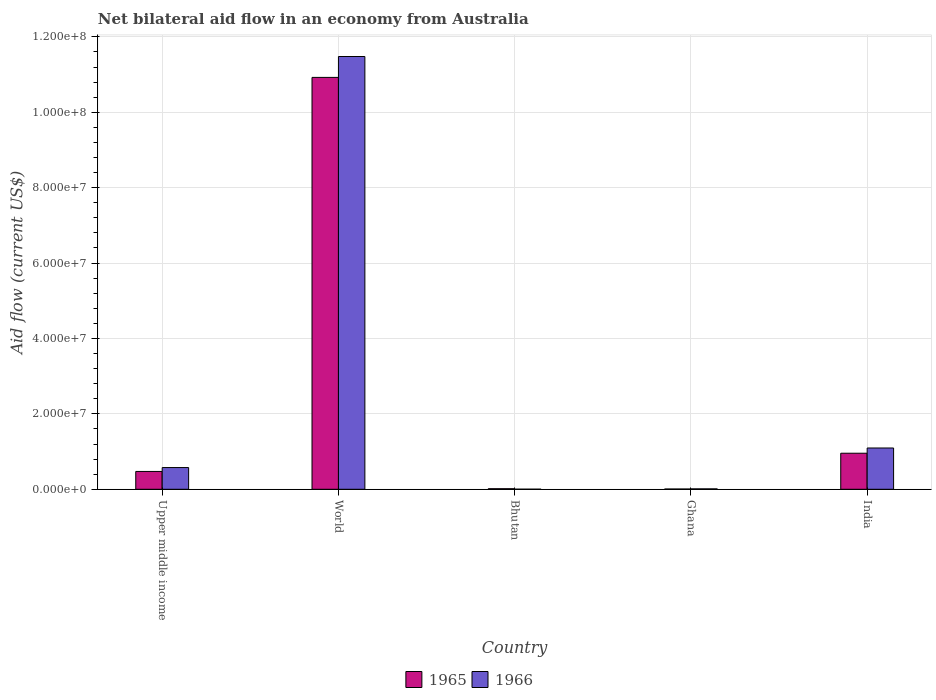How many different coloured bars are there?
Your response must be concise. 2. How many groups of bars are there?
Provide a succinct answer. 5. How many bars are there on the 4th tick from the left?
Your answer should be very brief. 2. How many bars are there on the 4th tick from the right?
Provide a short and direct response. 2. In how many cases, is the number of bars for a given country not equal to the number of legend labels?
Your answer should be compact. 0. Across all countries, what is the maximum net bilateral aid flow in 1965?
Your response must be concise. 1.09e+08. Across all countries, what is the minimum net bilateral aid flow in 1965?
Offer a terse response. 7.00e+04. In which country was the net bilateral aid flow in 1966 minimum?
Keep it short and to the point. Bhutan. What is the total net bilateral aid flow in 1966 in the graph?
Your response must be concise. 1.32e+08. What is the difference between the net bilateral aid flow in 1966 in Ghana and that in India?
Provide a succinct answer. -1.08e+07. What is the difference between the net bilateral aid flow in 1966 in Ghana and the net bilateral aid flow in 1965 in Bhutan?
Offer a very short reply. -4.00e+04. What is the average net bilateral aid flow in 1966 per country?
Give a very brief answer. 2.63e+07. What is the difference between the net bilateral aid flow of/in 1965 and net bilateral aid flow of/in 1966 in India?
Provide a short and direct response. -1.39e+06. What is the ratio of the net bilateral aid flow in 1965 in India to that in Upper middle income?
Keep it short and to the point. 2.02. What is the difference between the highest and the second highest net bilateral aid flow in 1965?
Your response must be concise. 1.05e+08. What is the difference between the highest and the lowest net bilateral aid flow in 1965?
Ensure brevity in your answer.  1.09e+08. In how many countries, is the net bilateral aid flow in 1966 greater than the average net bilateral aid flow in 1966 taken over all countries?
Your answer should be compact. 1. Is the sum of the net bilateral aid flow in 1966 in Bhutan and Upper middle income greater than the maximum net bilateral aid flow in 1965 across all countries?
Ensure brevity in your answer.  No. What does the 1st bar from the left in World represents?
Your response must be concise. 1965. What does the 1st bar from the right in Upper middle income represents?
Offer a very short reply. 1966. How many bars are there?
Your answer should be compact. 10. Are the values on the major ticks of Y-axis written in scientific E-notation?
Give a very brief answer. Yes. Does the graph contain any zero values?
Keep it short and to the point. No. Does the graph contain grids?
Provide a short and direct response. Yes. What is the title of the graph?
Your answer should be compact. Net bilateral aid flow in an economy from Australia. What is the label or title of the Y-axis?
Your answer should be very brief. Aid flow (current US$). What is the Aid flow (current US$) in 1965 in Upper middle income?
Your answer should be compact. 4.73e+06. What is the Aid flow (current US$) in 1966 in Upper middle income?
Provide a short and direct response. 5.76e+06. What is the Aid flow (current US$) of 1965 in World?
Your answer should be compact. 1.09e+08. What is the Aid flow (current US$) in 1966 in World?
Keep it short and to the point. 1.15e+08. What is the Aid flow (current US$) in 1965 in Bhutan?
Provide a short and direct response. 1.50e+05. What is the Aid flow (current US$) in 1966 in Bhutan?
Keep it short and to the point. 2.00e+04. What is the Aid flow (current US$) of 1965 in Ghana?
Provide a succinct answer. 7.00e+04. What is the Aid flow (current US$) in 1965 in India?
Ensure brevity in your answer.  9.56e+06. What is the Aid flow (current US$) of 1966 in India?
Make the answer very short. 1.10e+07. Across all countries, what is the maximum Aid flow (current US$) of 1965?
Ensure brevity in your answer.  1.09e+08. Across all countries, what is the maximum Aid flow (current US$) in 1966?
Ensure brevity in your answer.  1.15e+08. Across all countries, what is the minimum Aid flow (current US$) in 1966?
Your response must be concise. 2.00e+04. What is the total Aid flow (current US$) of 1965 in the graph?
Offer a very short reply. 1.24e+08. What is the total Aid flow (current US$) of 1966 in the graph?
Provide a short and direct response. 1.32e+08. What is the difference between the Aid flow (current US$) of 1965 in Upper middle income and that in World?
Your response must be concise. -1.05e+08. What is the difference between the Aid flow (current US$) in 1966 in Upper middle income and that in World?
Your answer should be very brief. -1.09e+08. What is the difference between the Aid flow (current US$) of 1965 in Upper middle income and that in Bhutan?
Keep it short and to the point. 4.58e+06. What is the difference between the Aid flow (current US$) in 1966 in Upper middle income and that in Bhutan?
Provide a succinct answer. 5.74e+06. What is the difference between the Aid flow (current US$) of 1965 in Upper middle income and that in Ghana?
Your response must be concise. 4.66e+06. What is the difference between the Aid flow (current US$) of 1966 in Upper middle income and that in Ghana?
Provide a succinct answer. 5.65e+06. What is the difference between the Aid flow (current US$) of 1965 in Upper middle income and that in India?
Give a very brief answer. -4.83e+06. What is the difference between the Aid flow (current US$) of 1966 in Upper middle income and that in India?
Your answer should be very brief. -5.19e+06. What is the difference between the Aid flow (current US$) of 1965 in World and that in Bhutan?
Provide a short and direct response. 1.09e+08. What is the difference between the Aid flow (current US$) of 1966 in World and that in Bhutan?
Provide a short and direct response. 1.15e+08. What is the difference between the Aid flow (current US$) in 1965 in World and that in Ghana?
Ensure brevity in your answer.  1.09e+08. What is the difference between the Aid flow (current US$) in 1966 in World and that in Ghana?
Provide a short and direct response. 1.15e+08. What is the difference between the Aid flow (current US$) of 1965 in World and that in India?
Provide a succinct answer. 9.97e+07. What is the difference between the Aid flow (current US$) in 1966 in World and that in India?
Provide a succinct answer. 1.04e+08. What is the difference between the Aid flow (current US$) in 1965 in Bhutan and that in Ghana?
Your response must be concise. 8.00e+04. What is the difference between the Aid flow (current US$) of 1965 in Bhutan and that in India?
Offer a very short reply. -9.41e+06. What is the difference between the Aid flow (current US$) in 1966 in Bhutan and that in India?
Offer a terse response. -1.09e+07. What is the difference between the Aid flow (current US$) in 1965 in Ghana and that in India?
Your response must be concise. -9.49e+06. What is the difference between the Aid flow (current US$) of 1966 in Ghana and that in India?
Keep it short and to the point. -1.08e+07. What is the difference between the Aid flow (current US$) of 1965 in Upper middle income and the Aid flow (current US$) of 1966 in World?
Offer a very short reply. -1.10e+08. What is the difference between the Aid flow (current US$) in 1965 in Upper middle income and the Aid flow (current US$) in 1966 in Bhutan?
Your answer should be very brief. 4.71e+06. What is the difference between the Aid flow (current US$) in 1965 in Upper middle income and the Aid flow (current US$) in 1966 in Ghana?
Offer a terse response. 4.62e+06. What is the difference between the Aid flow (current US$) of 1965 in Upper middle income and the Aid flow (current US$) of 1966 in India?
Provide a succinct answer. -6.22e+06. What is the difference between the Aid flow (current US$) in 1965 in World and the Aid flow (current US$) in 1966 in Bhutan?
Offer a terse response. 1.09e+08. What is the difference between the Aid flow (current US$) of 1965 in World and the Aid flow (current US$) of 1966 in Ghana?
Keep it short and to the point. 1.09e+08. What is the difference between the Aid flow (current US$) of 1965 in World and the Aid flow (current US$) of 1966 in India?
Make the answer very short. 9.83e+07. What is the difference between the Aid flow (current US$) of 1965 in Bhutan and the Aid flow (current US$) of 1966 in India?
Your answer should be very brief. -1.08e+07. What is the difference between the Aid flow (current US$) of 1965 in Ghana and the Aid flow (current US$) of 1966 in India?
Keep it short and to the point. -1.09e+07. What is the average Aid flow (current US$) in 1965 per country?
Provide a succinct answer. 2.48e+07. What is the average Aid flow (current US$) in 1966 per country?
Your response must be concise. 2.63e+07. What is the difference between the Aid flow (current US$) in 1965 and Aid flow (current US$) in 1966 in Upper middle income?
Give a very brief answer. -1.03e+06. What is the difference between the Aid flow (current US$) in 1965 and Aid flow (current US$) in 1966 in World?
Your response must be concise. -5.54e+06. What is the difference between the Aid flow (current US$) of 1965 and Aid flow (current US$) of 1966 in Bhutan?
Give a very brief answer. 1.30e+05. What is the difference between the Aid flow (current US$) of 1965 and Aid flow (current US$) of 1966 in Ghana?
Offer a terse response. -4.00e+04. What is the difference between the Aid flow (current US$) of 1965 and Aid flow (current US$) of 1966 in India?
Give a very brief answer. -1.39e+06. What is the ratio of the Aid flow (current US$) in 1965 in Upper middle income to that in World?
Ensure brevity in your answer.  0.04. What is the ratio of the Aid flow (current US$) in 1966 in Upper middle income to that in World?
Keep it short and to the point. 0.05. What is the ratio of the Aid flow (current US$) of 1965 in Upper middle income to that in Bhutan?
Offer a terse response. 31.53. What is the ratio of the Aid flow (current US$) of 1966 in Upper middle income to that in Bhutan?
Provide a succinct answer. 288. What is the ratio of the Aid flow (current US$) of 1965 in Upper middle income to that in Ghana?
Make the answer very short. 67.57. What is the ratio of the Aid flow (current US$) in 1966 in Upper middle income to that in Ghana?
Your response must be concise. 52.36. What is the ratio of the Aid flow (current US$) of 1965 in Upper middle income to that in India?
Make the answer very short. 0.49. What is the ratio of the Aid flow (current US$) in 1966 in Upper middle income to that in India?
Your answer should be very brief. 0.53. What is the ratio of the Aid flow (current US$) of 1965 in World to that in Bhutan?
Your response must be concise. 728.33. What is the ratio of the Aid flow (current US$) of 1966 in World to that in Bhutan?
Offer a very short reply. 5739.5. What is the ratio of the Aid flow (current US$) in 1965 in World to that in Ghana?
Provide a succinct answer. 1560.71. What is the ratio of the Aid flow (current US$) of 1966 in World to that in Ghana?
Your answer should be very brief. 1043.55. What is the ratio of the Aid flow (current US$) in 1965 in World to that in India?
Your answer should be compact. 11.43. What is the ratio of the Aid flow (current US$) in 1966 in World to that in India?
Your answer should be compact. 10.48. What is the ratio of the Aid flow (current US$) in 1965 in Bhutan to that in Ghana?
Make the answer very short. 2.14. What is the ratio of the Aid flow (current US$) of 1966 in Bhutan to that in Ghana?
Your response must be concise. 0.18. What is the ratio of the Aid flow (current US$) in 1965 in Bhutan to that in India?
Give a very brief answer. 0.02. What is the ratio of the Aid flow (current US$) of 1966 in Bhutan to that in India?
Ensure brevity in your answer.  0. What is the ratio of the Aid flow (current US$) of 1965 in Ghana to that in India?
Offer a very short reply. 0.01. What is the ratio of the Aid flow (current US$) in 1966 in Ghana to that in India?
Provide a succinct answer. 0.01. What is the difference between the highest and the second highest Aid flow (current US$) in 1965?
Make the answer very short. 9.97e+07. What is the difference between the highest and the second highest Aid flow (current US$) of 1966?
Your answer should be very brief. 1.04e+08. What is the difference between the highest and the lowest Aid flow (current US$) in 1965?
Your answer should be compact. 1.09e+08. What is the difference between the highest and the lowest Aid flow (current US$) in 1966?
Your response must be concise. 1.15e+08. 